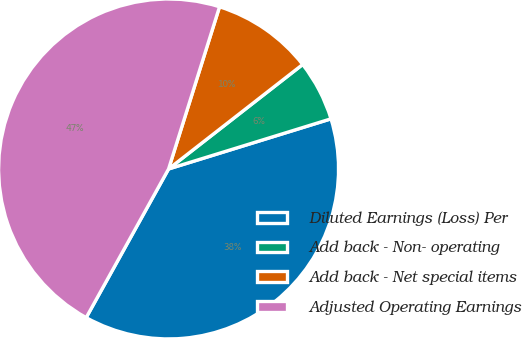Convert chart. <chart><loc_0><loc_0><loc_500><loc_500><pie_chart><fcel>Diluted Earnings (Loss) Per<fcel>Add back - Non- operating<fcel>Add back - Net special items<fcel>Adjusted Operating Earnings<nl><fcel>37.82%<fcel>5.77%<fcel>9.62%<fcel>46.79%<nl></chart> 